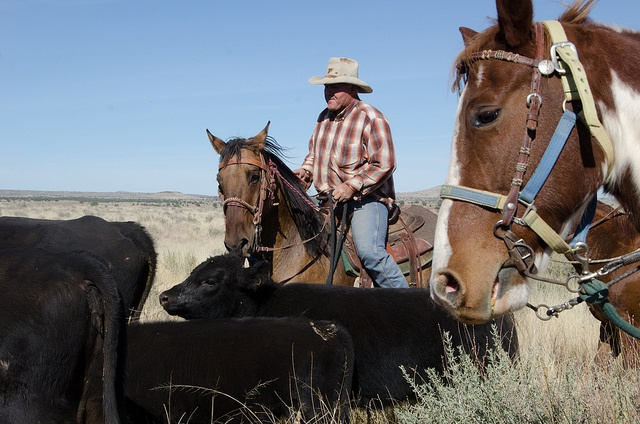Describe the objects in this image and their specific colors. I can see horse in darkgray, maroon, black, and gray tones, cow in darkgray, black, and gray tones, cow in darkgray, black, and gray tones, cow in darkgray, black, and gray tones, and horse in darkgray, black, gray, and maroon tones in this image. 